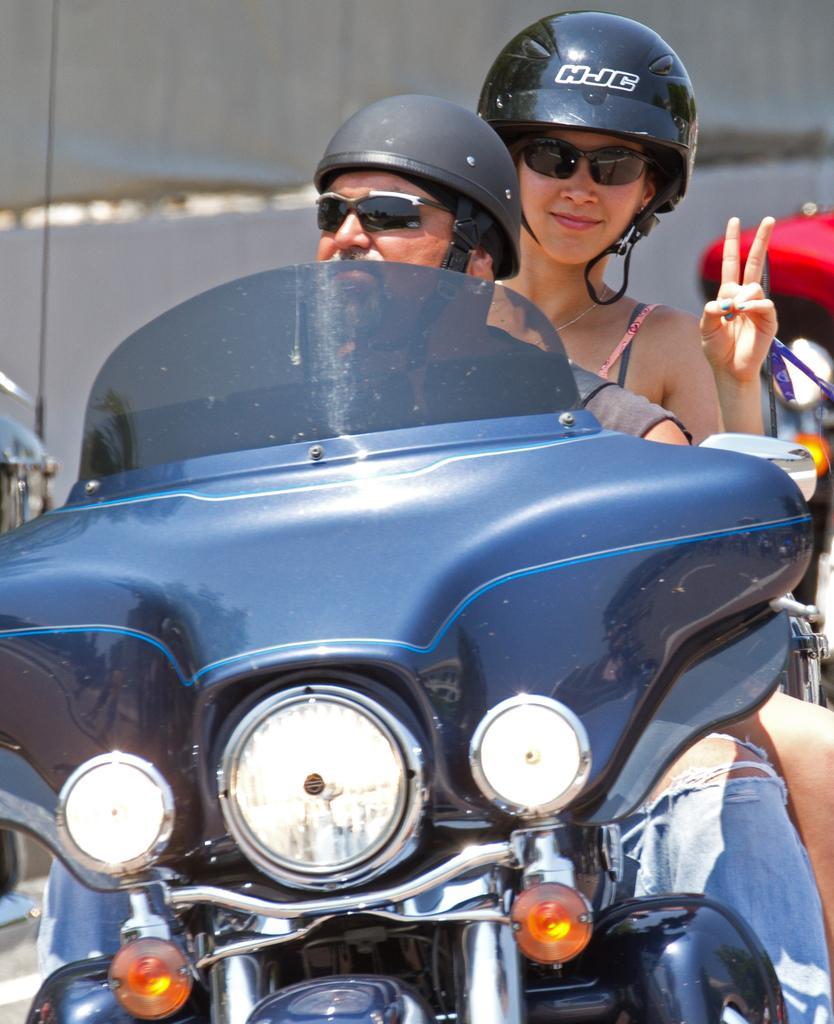In one or two sentences, can you explain what this image depicts? In this picture, there is a men and women who is riding a bike. In the front we can see a lights of a bike. A woman who is wearing a goggles and helmet and she is showing a two fingers. On the background there is a building. On the left there is a red tent. 